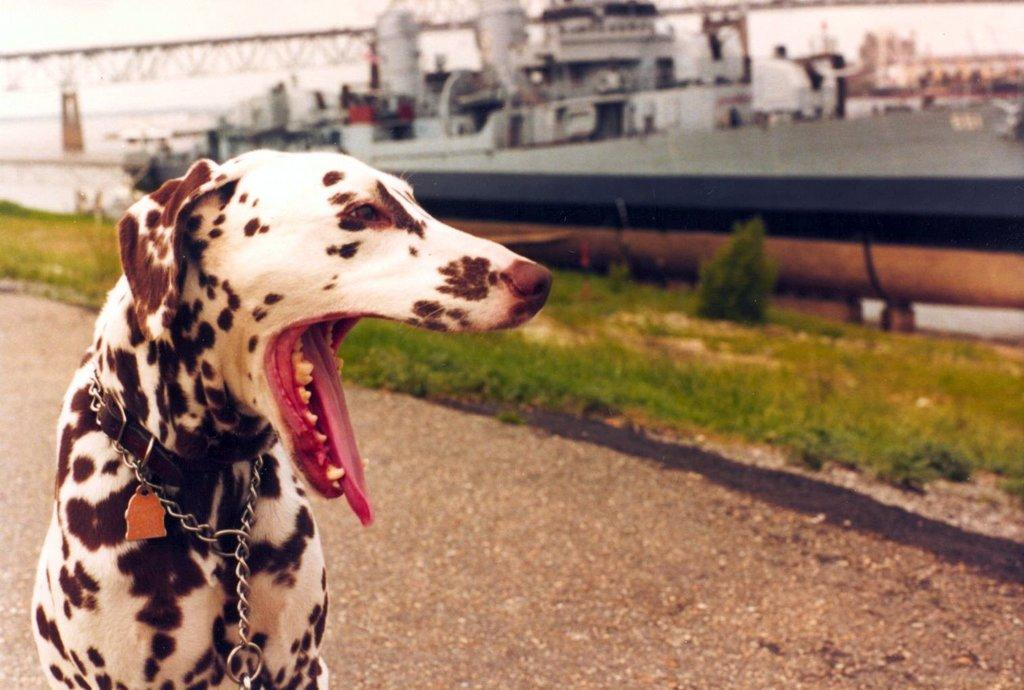What type of dog is in the image? There is a Dalmatian dog in the image. Is the dog wearing any accessories in the image? Yes, the dog has a chain around its neck. What can be seen behind the dog in the image? There is a big machine behind the dog. What is the ground surface like in front of the machine? There is grass in front of the machine. What type of ink is being used by the dog in the image? There is no ink present in the image, and the dog is not using any ink. 